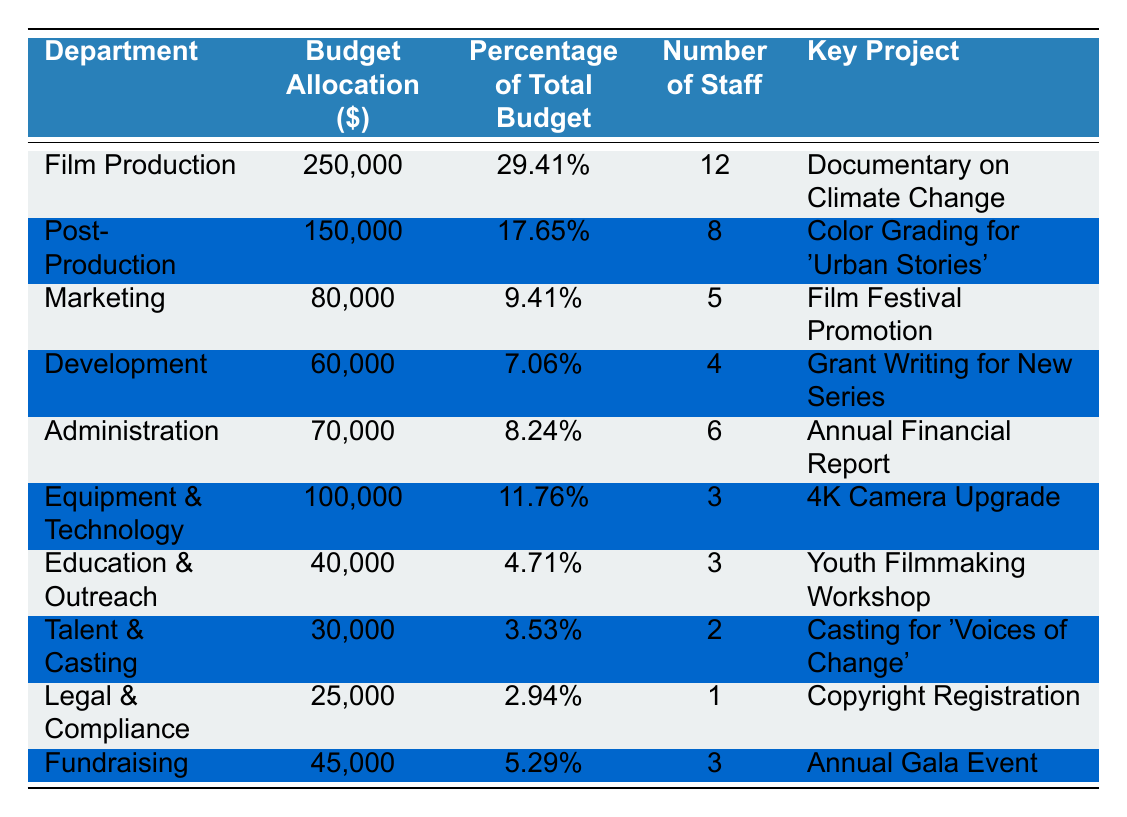What is the budget allocation for the Marketing department? The table shows that the budget allocation for the Marketing department is listed directly in the Budget Allocation column next to Marketing. The value is 80,000.
Answer: 80,000 Which department has the highest percentage of the total budget? By comparing the Percentage of Total Budget for all departments in the table, the Film Production department has the highest percentage at 29.41%.
Answer: Film Production How many staff members are assigned to the Legal & Compliance department? The number of staff for the Legal & Compliance department is found in the Number of Staff column next to it, which states there is 1 staff member.
Answer: 1 What is the total budget allocation for the Education & Outreach and Talent & Casting departments combined? The budget allocations for both departments are 40,000 for Education & Outreach and 30,000 for Talent & Casting. The total is calculated by summing these values: 40,000 + 30,000 = 70,000.
Answer: 70,000 Does the Equipment & Technology department have more staff than the Education & Outreach department? The Equipment & Technology department has 3 staff members while the Education & Outreach department also has 3 staff members. Therefore, both departments have the same number of staff.
Answer: No What is the average budget allocation across all departments? First, sum the budget allocations: 250,000 + 150,000 + 80,000 + 60,000 + 70,000 + 100,000 + 40,000 + 30,000 + 25,000 + 45,000 = 830,000. There are 10 departments, so the average is 830,000 / 10 = 83,000.
Answer: 83,000 Which department is focused on legal matters? The table lists the Legal & Compliance department, which indicates its focus on legal matters explicitly.
Answer: Legal & Compliance What percentage of the total budget is allocated to the Administration department? The Percentage of Total Budget for the Administration department is listed in the respective column as 8.24%.
Answer: 8.24% Which department has the least budget allocation? The table shows that the Legal & Compliance department has the least budget allocation of 25,000.
Answer: Legal & Compliance If you combine the budgets for Film Production and Post-Production, what is the total amount? The budget for Film Production is 250,000, and for Post-Production, it is 150,000. The total is calculated by adding these two amounts: 250,000 + 150,000 = 400,000.
Answer: 400,000 Are there any departments that only have 2 staff members? The Talent & Casting department is listed with exactly 2 staff members, which indicates that it is the only department fitting this criterion.
Answer: Yes 